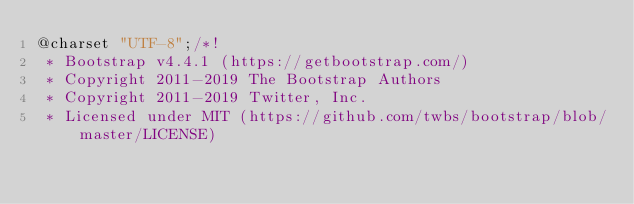<code> <loc_0><loc_0><loc_500><loc_500><_CSS_>@charset "UTF-8";/*!
 * Bootstrap v4.4.1 (https://getbootstrap.com/)
 * Copyright 2011-2019 The Bootstrap Authors
 * Copyright 2011-2019 Twitter, Inc.
 * Licensed under MIT (https://github.com/twbs/bootstrap/blob/master/LICENSE)</code> 